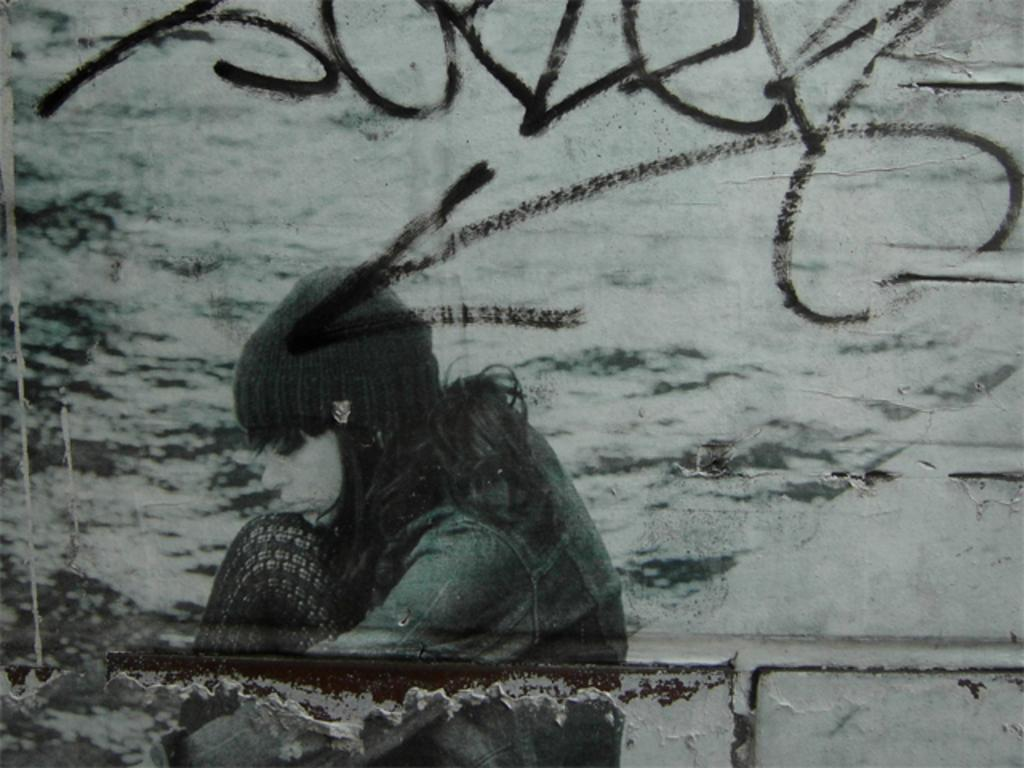Who is the main subject in the picture? There is a girl in the picture. What is the girl wearing on her head? The girl is wearing a cap. What type of clothing is the girl wearing on her upper body? The girl is wearing a jacket. What is the girl doing in the picture? The girl is sitting. What can be seen on the wall in the picture? There is text on the wall in the picture. What type of degree is the girl studying for in the picture? There is no indication in the image that the girl is studying for a degree, nor is there any information about her academic pursuits. 